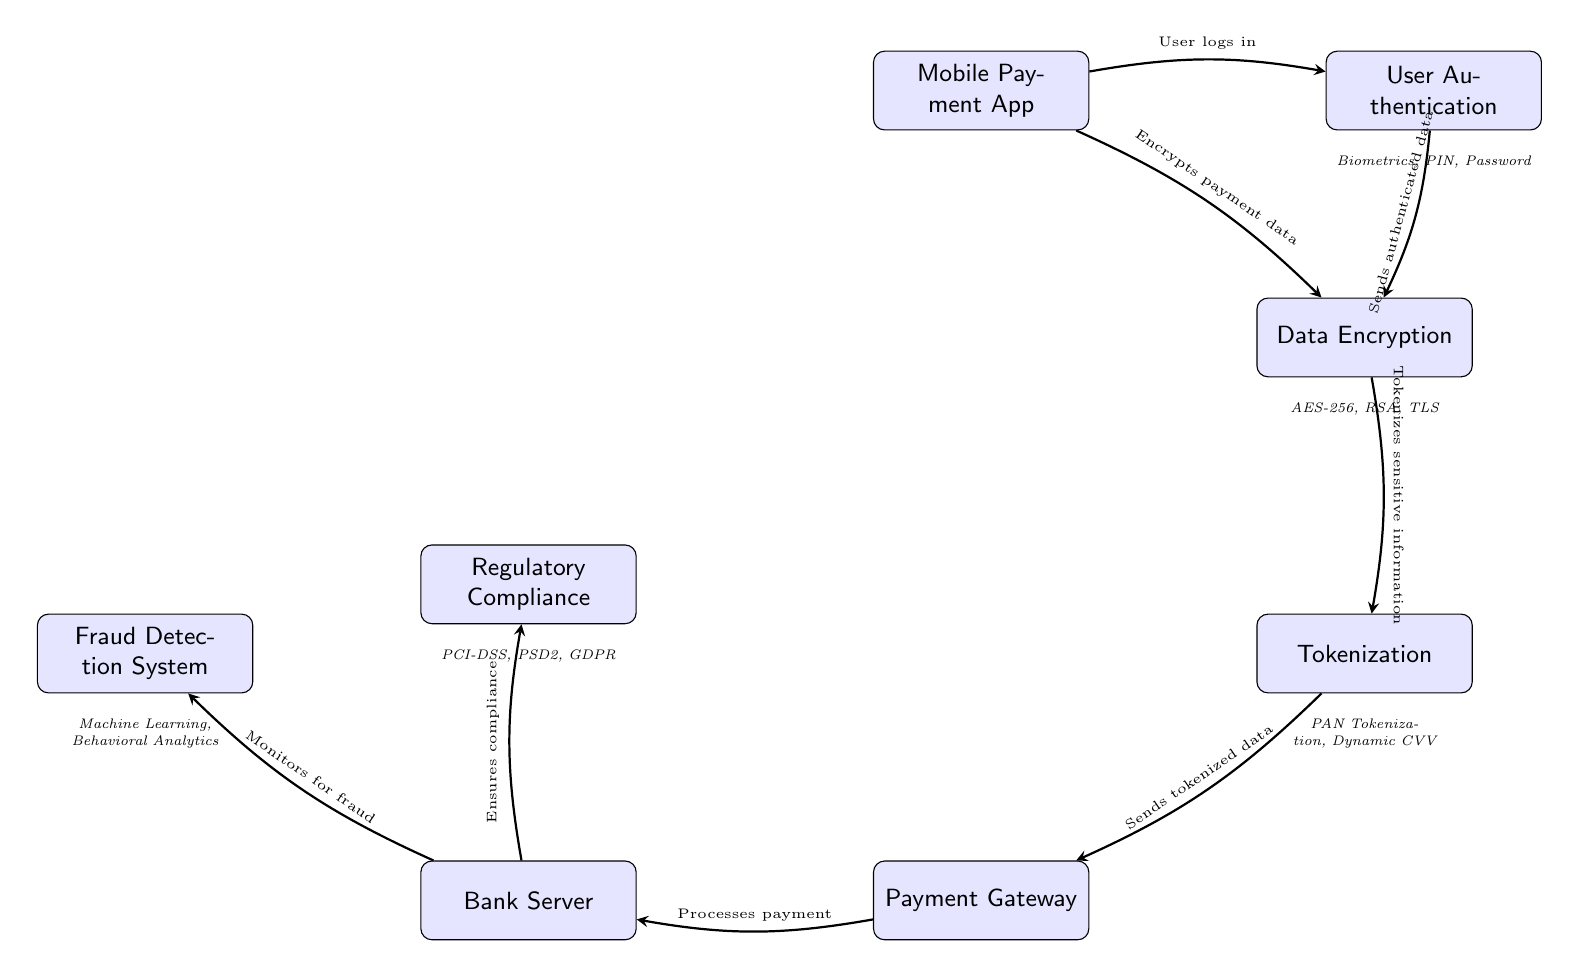What is the first node in the diagram? The first node in the diagram is "Mobile Payment App," as it is positioned at the top of the diagram and is the starting point for the flow.
Answer: Mobile Payment App What type of data encryption method is listed in the diagram? The diagram indicates "AES-256, RSA, TLS" as the encryption methods under the "Data Encryption" node, referring to specific standards for data security.
Answer: AES-256, RSA, TLS How many nodes are present in the diagram? By counting each unique node in the diagram, we find there are eight nodes, representing various components of the mobile payment security process.
Answer: 8 Which node is responsible for monitoring for fraud? The node labeled "Fraud Detection System" is directly connected to the "Bank Server," and it is responsible for monitoring for any fraudulent activity.
Answer: Fraud Detection System What does the "Payment Gateway" node send? The "Payment Gateway" node sends "tokenized data" to the "Bank Server," which is part of the process of securely handling payment processes.
Answer: Sends tokenized data What types of user authentication methods are mentioned in the diagram? The diagram lists "Biometrics, PIN, Password" under the "User Authentication" node, indicating different authentication mechanisms available for users.
Answer: Biometrics, PIN, Password Which node ensures compliance with regulations? The "Regulatory Compliance" node directly indicates that it ensures compliance with relevant laws and regulations in the context of mobile payments.
Answer: Regulatory Compliance Explain the relationship between "Data Encryption" and "Tokenization." The "Data Encryption" node is followed by the "Tokenization" node in the diagram; this indicates that after encrypting the payment data, the next step is to tokenize the sensitive information for added security during transactions.
Answer: Tokenizes sensitive information What two systems does the "Bank Server" communicate with? The "Bank Server" node communicates with two systems: the "Fraud Detection System" and the "Regulatory Compliance," as shown by the directed edges leading to these nodes.
Answer: Fraud Detection System, Regulatory Compliance 